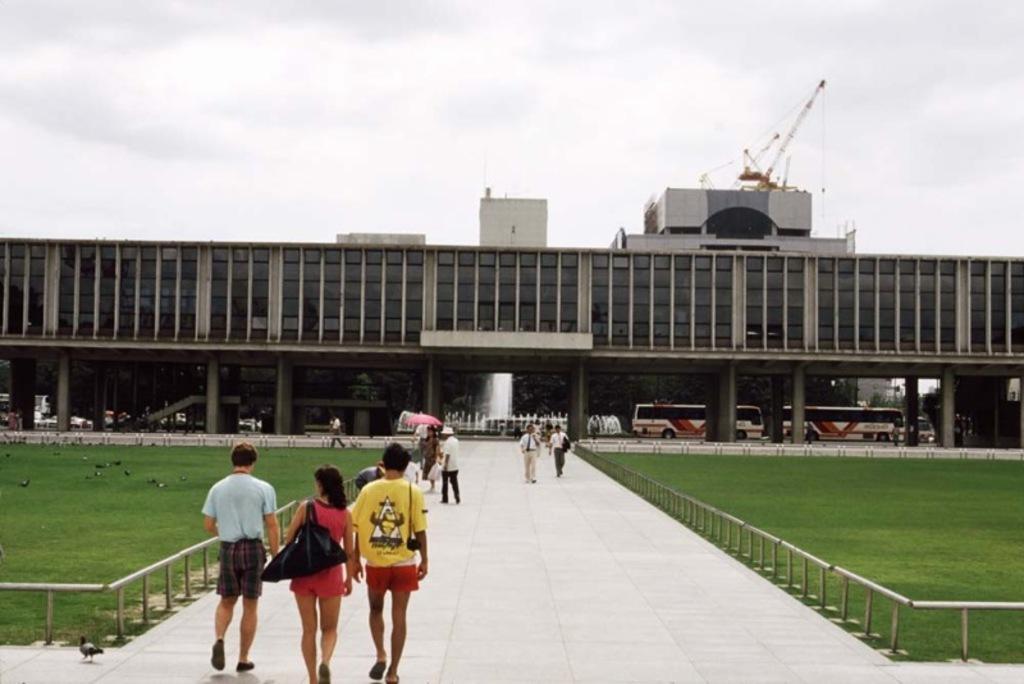How would you summarize this image in a sentence or two? In this image, there are some persons wearing clothes and walking on the path. There is a grass in the bottom left and in the bottom right of the image. There is a building in the middle of the image. There are vehicles under the building. There is a sky at the top of the image. 